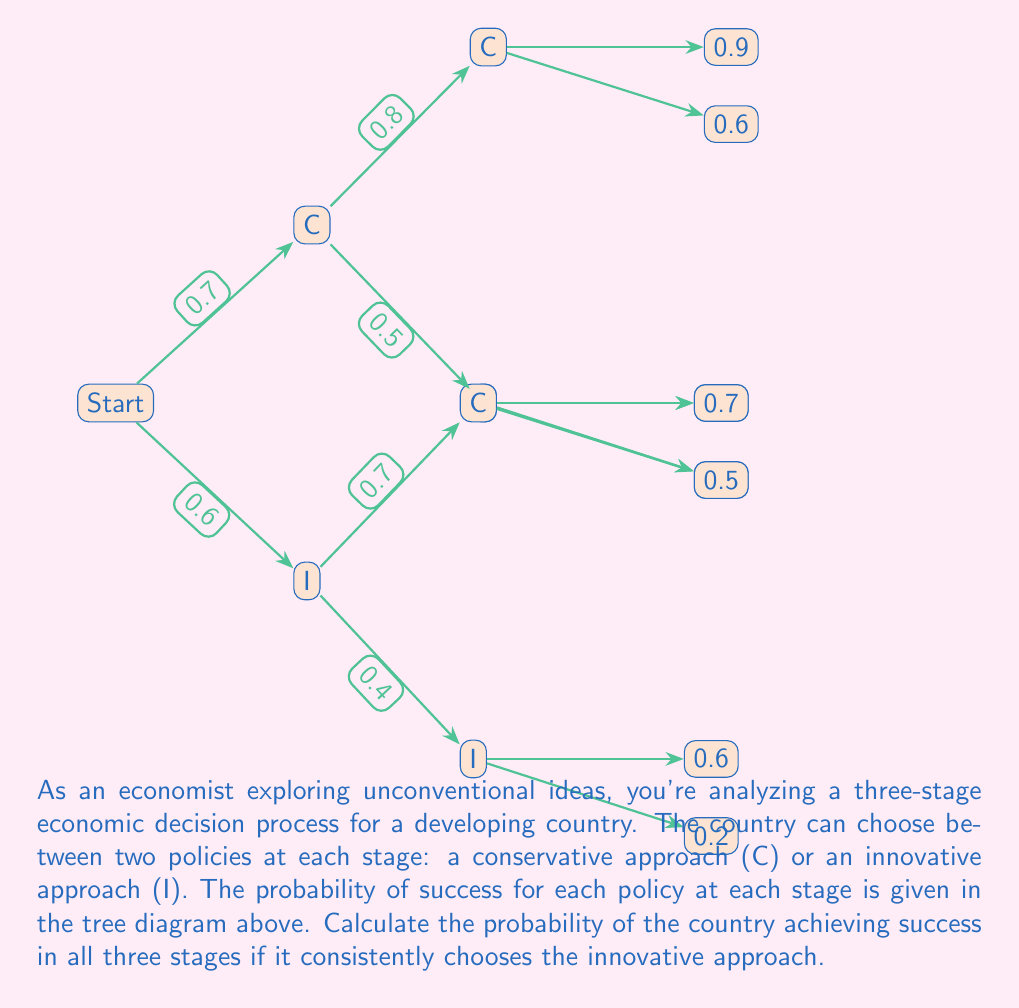Help me with this question. To solve this problem, we need to follow the path of innovative (I) choices through the tree diagram and multiply the probabilities along this path. Let's break it down step-by-step:

1. First stage: The probability of success for the innovative approach is 0.6.

2. Second stage: Following the innovative path, we see that the probability of success for the innovative approach in the second stage is 0.4.

3. Third stage: Continuing on the innovative path, the probability of success for the innovative approach in the third stage is 0.2.

4. To calculate the probability of success in all three stages while consistently choosing the innovative approach, we multiply these probabilities:

   $$P(\text{Success all stages}) = P(\text{Stage 1}) \times P(\text{Stage 2}) \times P(\text{Stage 3})$$
   $$P(\text{Success all stages}) = 0.6 \times 0.4 \times 0.2$$

5. Calculating this:
   $$P(\text{Success all stages}) = 0.048$$

Therefore, the probability of achieving success in all three stages while consistently choosing the innovative approach is 0.048 or 4.8%.
Answer: 0.048 